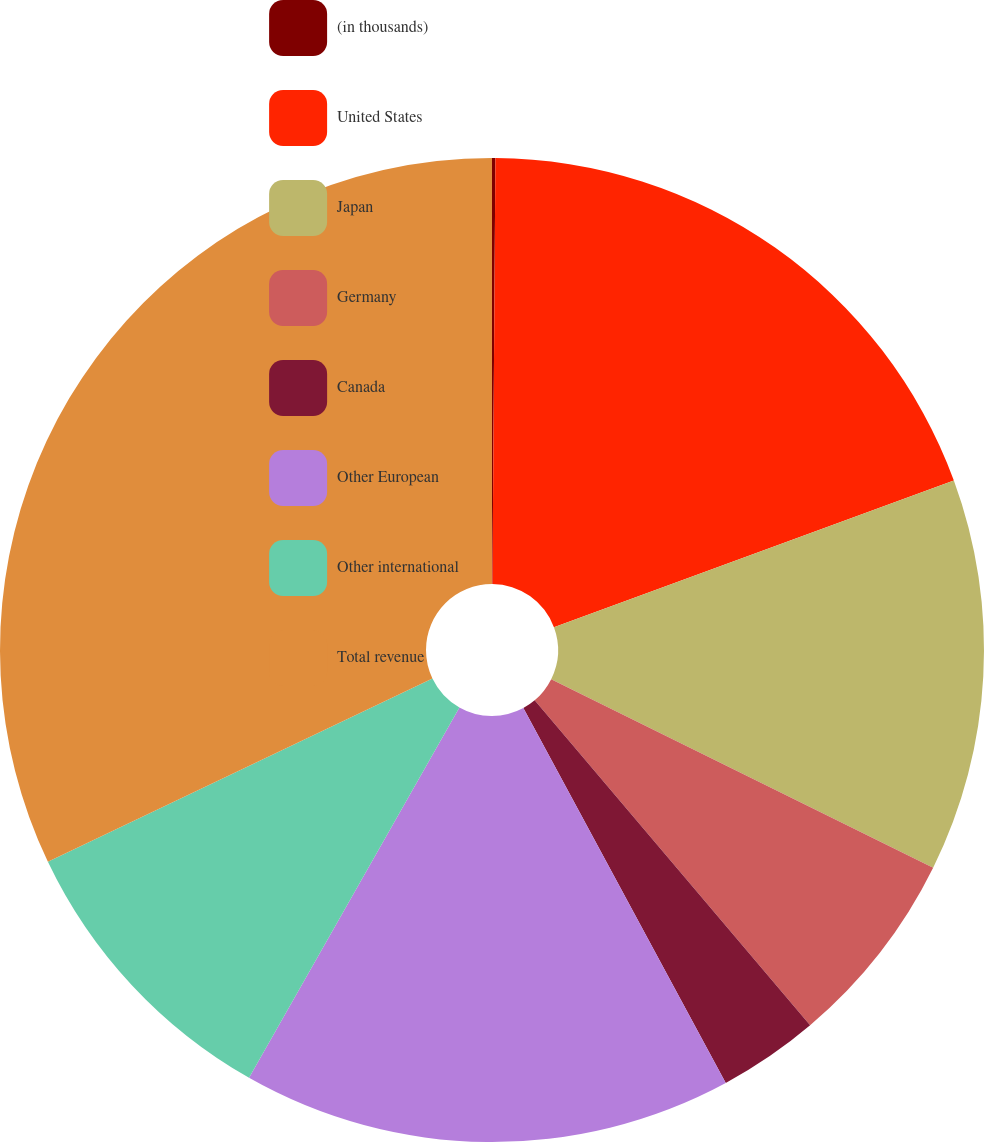Convert chart. <chart><loc_0><loc_0><loc_500><loc_500><pie_chart><fcel>(in thousands)<fcel>United States<fcel>Japan<fcel>Germany<fcel>Canada<fcel>Other European<fcel>Other international<fcel>Total revenue<nl><fcel>0.11%<fcel>19.29%<fcel>12.9%<fcel>6.51%<fcel>3.31%<fcel>16.1%<fcel>9.7%<fcel>32.08%<nl></chart> 